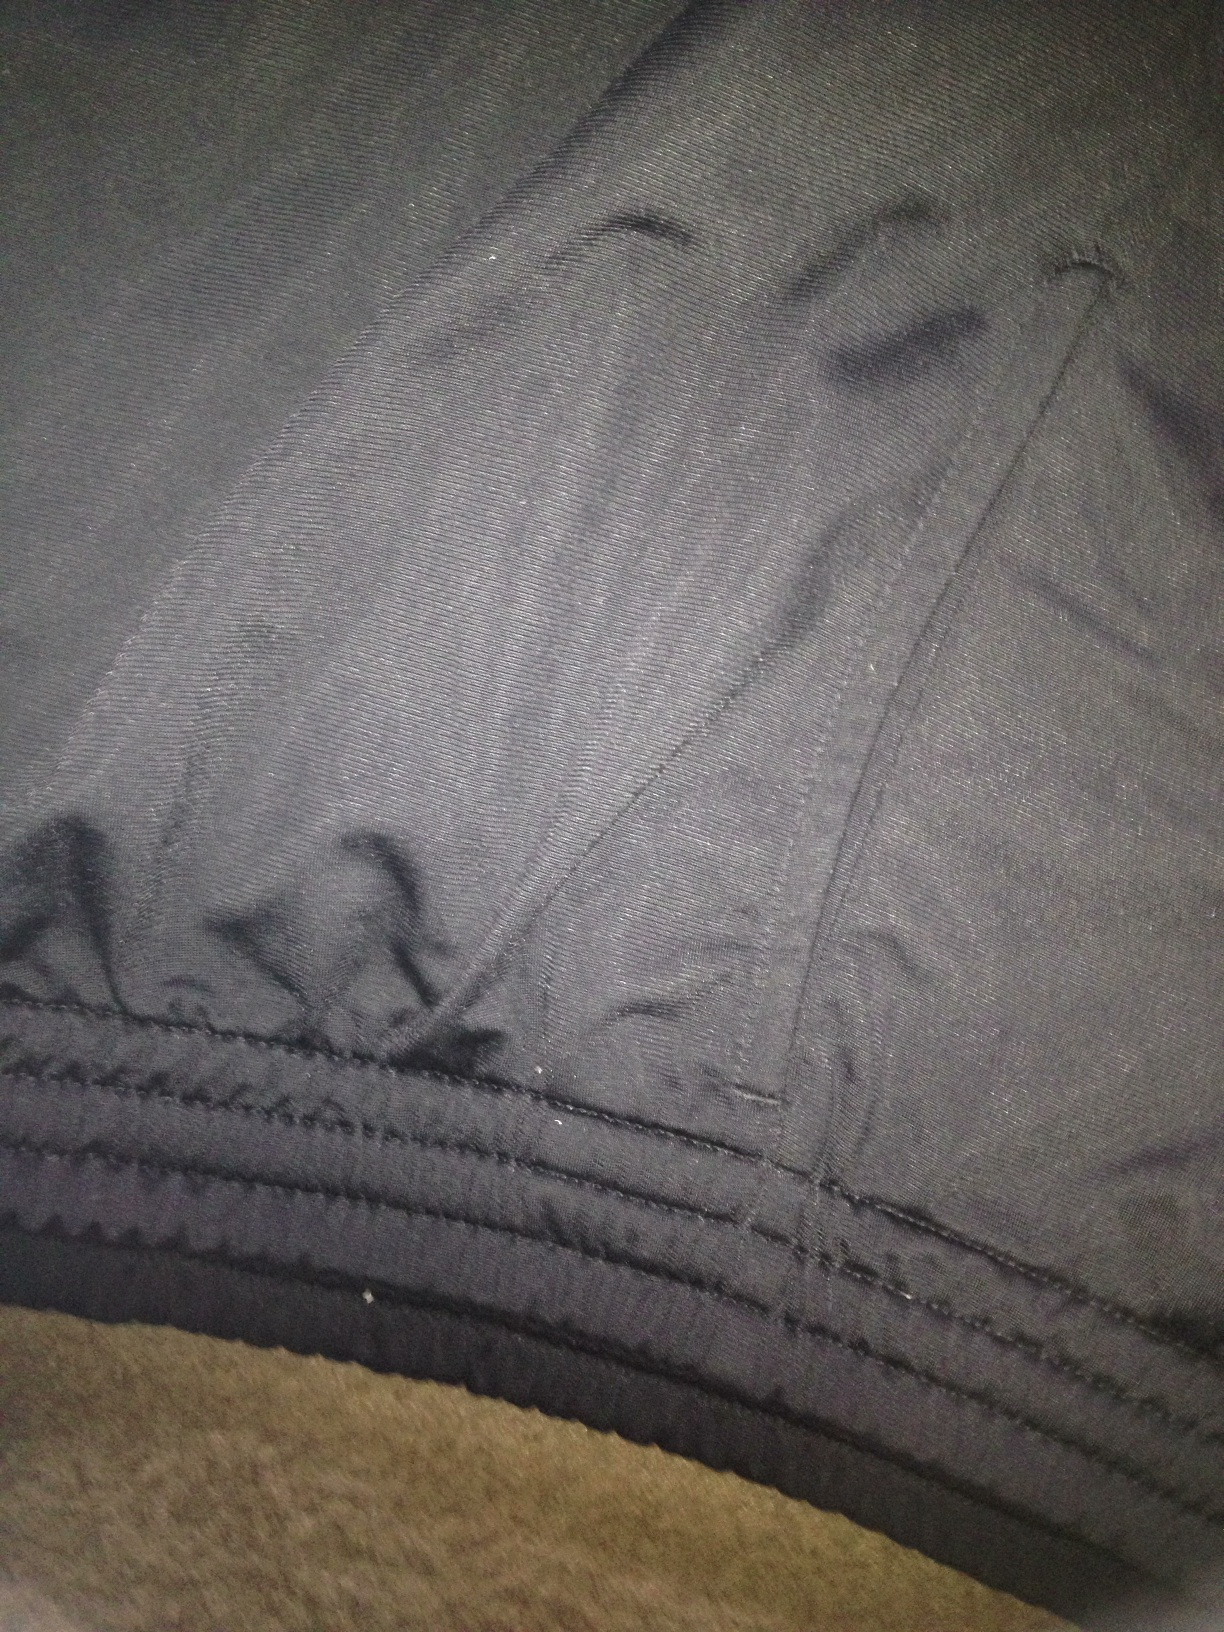If these pants could talk, what story would they tell? These pants might tell the story of countless adventures, from casual outings with friends to impromptu road trips. They'd recall the cozy days lounging at home, as well as the bustling city streets they’ve walked. Worn by someone who values both comfort and style, these pants have witnessed a past full of moments both ordinary and extraordinary, all while enduring as a staple in their owner's wardrobe. 